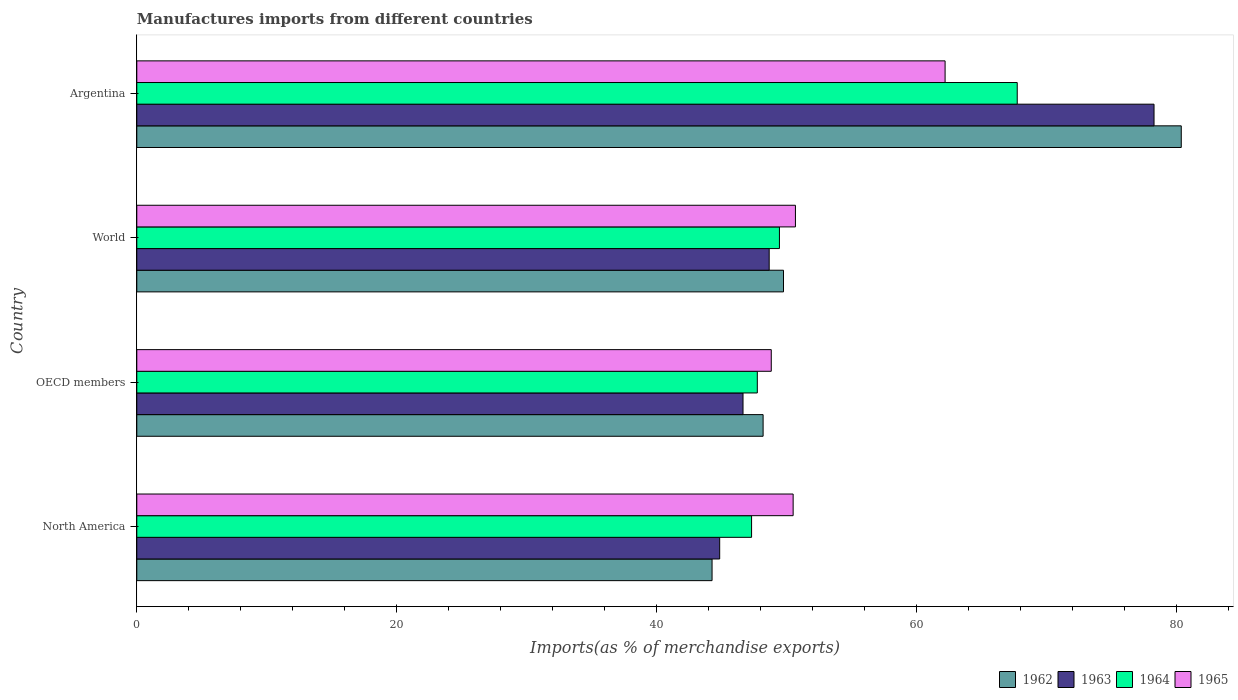How many groups of bars are there?
Give a very brief answer. 4. Are the number of bars on each tick of the Y-axis equal?
Your answer should be very brief. Yes. How many bars are there on the 1st tick from the bottom?
Provide a succinct answer. 4. What is the label of the 4th group of bars from the top?
Your answer should be very brief. North America. In how many cases, is the number of bars for a given country not equal to the number of legend labels?
Your answer should be very brief. 0. What is the percentage of imports to different countries in 1965 in World?
Your response must be concise. 50.68. Across all countries, what is the maximum percentage of imports to different countries in 1963?
Offer a terse response. 78.27. Across all countries, what is the minimum percentage of imports to different countries in 1962?
Give a very brief answer. 44.26. In which country was the percentage of imports to different countries in 1963 maximum?
Your response must be concise. Argentina. In which country was the percentage of imports to different countries in 1963 minimum?
Provide a short and direct response. North America. What is the total percentage of imports to different countries in 1962 in the graph?
Your answer should be compact. 222.58. What is the difference between the percentage of imports to different countries in 1963 in Argentina and that in OECD members?
Your answer should be compact. 31.62. What is the difference between the percentage of imports to different countries in 1964 in OECD members and the percentage of imports to different countries in 1963 in Argentina?
Your answer should be very brief. -30.53. What is the average percentage of imports to different countries in 1963 per country?
Provide a succinct answer. 54.61. What is the difference between the percentage of imports to different countries in 1965 and percentage of imports to different countries in 1964 in World?
Make the answer very short. 1.23. In how many countries, is the percentage of imports to different countries in 1964 greater than 60 %?
Keep it short and to the point. 1. What is the ratio of the percentage of imports to different countries in 1962 in Argentina to that in North America?
Your answer should be compact. 1.82. Is the percentage of imports to different countries in 1964 in North America less than that in OECD members?
Make the answer very short. Yes. What is the difference between the highest and the second highest percentage of imports to different countries in 1963?
Give a very brief answer. 29.61. What is the difference between the highest and the lowest percentage of imports to different countries in 1963?
Provide a short and direct response. 33.42. Is the sum of the percentage of imports to different countries in 1963 in OECD members and World greater than the maximum percentage of imports to different countries in 1965 across all countries?
Keep it short and to the point. Yes. Is it the case that in every country, the sum of the percentage of imports to different countries in 1963 and percentage of imports to different countries in 1964 is greater than the sum of percentage of imports to different countries in 1965 and percentage of imports to different countries in 1962?
Provide a short and direct response. No. What does the 3rd bar from the top in North America represents?
Provide a short and direct response. 1963. What does the 1st bar from the bottom in North America represents?
Make the answer very short. 1962. How many bars are there?
Make the answer very short. 16. How many countries are there in the graph?
Provide a short and direct response. 4. What is the difference between two consecutive major ticks on the X-axis?
Ensure brevity in your answer.  20. Are the values on the major ticks of X-axis written in scientific E-notation?
Your response must be concise. No. Does the graph contain any zero values?
Your answer should be very brief. No. Does the graph contain grids?
Keep it short and to the point. No. How many legend labels are there?
Your answer should be compact. 4. How are the legend labels stacked?
Make the answer very short. Horizontal. What is the title of the graph?
Ensure brevity in your answer.  Manufactures imports from different countries. Does "1995" appear as one of the legend labels in the graph?
Your response must be concise. No. What is the label or title of the X-axis?
Keep it short and to the point. Imports(as % of merchandise exports). What is the Imports(as % of merchandise exports) of 1962 in North America?
Your answer should be very brief. 44.26. What is the Imports(as % of merchandise exports) in 1963 in North America?
Keep it short and to the point. 44.85. What is the Imports(as % of merchandise exports) of 1964 in North America?
Keep it short and to the point. 47.3. What is the Imports(as % of merchandise exports) in 1965 in North America?
Your response must be concise. 50.5. What is the Imports(as % of merchandise exports) in 1962 in OECD members?
Your response must be concise. 48.19. What is the Imports(as % of merchandise exports) of 1963 in OECD members?
Keep it short and to the point. 46.65. What is the Imports(as % of merchandise exports) in 1964 in OECD members?
Your answer should be compact. 47.75. What is the Imports(as % of merchandise exports) in 1965 in OECD members?
Your answer should be compact. 48.82. What is the Imports(as % of merchandise exports) in 1962 in World?
Offer a terse response. 49.76. What is the Imports(as % of merchandise exports) of 1963 in World?
Give a very brief answer. 48.66. What is the Imports(as % of merchandise exports) of 1964 in World?
Provide a succinct answer. 49.45. What is the Imports(as % of merchandise exports) of 1965 in World?
Provide a short and direct response. 50.68. What is the Imports(as % of merchandise exports) of 1962 in Argentina?
Offer a terse response. 80.37. What is the Imports(as % of merchandise exports) in 1963 in Argentina?
Your response must be concise. 78.27. What is the Imports(as % of merchandise exports) in 1964 in Argentina?
Keep it short and to the point. 67.75. What is the Imports(as % of merchandise exports) in 1965 in Argentina?
Your answer should be very brief. 62.19. Across all countries, what is the maximum Imports(as % of merchandise exports) of 1962?
Offer a very short reply. 80.37. Across all countries, what is the maximum Imports(as % of merchandise exports) of 1963?
Offer a terse response. 78.27. Across all countries, what is the maximum Imports(as % of merchandise exports) in 1964?
Provide a succinct answer. 67.75. Across all countries, what is the maximum Imports(as % of merchandise exports) in 1965?
Your answer should be compact. 62.19. Across all countries, what is the minimum Imports(as % of merchandise exports) of 1962?
Make the answer very short. 44.26. Across all countries, what is the minimum Imports(as % of merchandise exports) of 1963?
Make the answer very short. 44.85. Across all countries, what is the minimum Imports(as % of merchandise exports) in 1964?
Offer a very short reply. 47.3. Across all countries, what is the minimum Imports(as % of merchandise exports) in 1965?
Your response must be concise. 48.82. What is the total Imports(as % of merchandise exports) in 1962 in the graph?
Your answer should be compact. 222.58. What is the total Imports(as % of merchandise exports) in 1963 in the graph?
Offer a terse response. 218.43. What is the total Imports(as % of merchandise exports) of 1964 in the graph?
Your answer should be very brief. 212.24. What is the total Imports(as % of merchandise exports) in 1965 in the graph?
Offer a terse response. 212.2. What is the difference between the Imports(as % of merchandise exports) of 1962 in North America and that in OECD members?
Give a very brief answer. -3.93. What is the difference between the Imports(as % of merchandise exports) of 1963 in North America and that in OECD members?
Your answer should be compact. -1.8. What is the difference between the Imports(as % of merchandise exports) in 1964 in North America and that in OECD members?
Your answer should be compact. -0.44. What is the difference between the Imports(as % of merchandise exports) of 1965 in North America and that in OECD members?
Make the answer very short. 1.68. What is the difference between the Imports(as % of merchandise exports) in 1962 in North America and that in World?
Make the answer very short. -5.5. What is the difference between the Imports(as % of merchandise exports) of 1963 in North America and that in World?
Offer a very short reply. -3.81. What is the difference between the Imports(as % of merchandise exports) of 1964 in North America and that in World?
Ensure brevity in your answer.  -2.14. What is the difference between the Imports(as % of merchandise exports) in 1965 in North America and that in World?
Your answer should be compact. -0.18. What is the difference between the Imports(as % of merchandise exports) in 1962 in North America and that in Argentina?
Offer a terse response. -36.1. What is the difference between the Imports(as % of merchandise exports) in 1963 in North America and that in Argentina?
Offer a terse response. -33.42. What is the difference between the Imports(as % of merchandise exports) of 1964 in North America and that in Argentina?
Give a very brief answer. -20.44. What is the difference between the Imports(as % of merchandise exports) of 1965 in North America and that in Argentina?
Provide a short and direct response. -11.69. What is the difference between the Imports(as % of merchandise exports) of 1962 in OECD members and that in World?
Your answer should be very brief. -1.57. What is the difference between the Imports(as % of merchandise exports) in 1963 in OECD members and that in World?
Keep it short and to the point. -2.01. What is the difference between the Imports(as % of merchandise exports) of 1964 in OECD members and that in World?
Give a very brief answer. -1.7. What is the difference between the Imports(as % of merchandise exports) in 1965 in OECD members and that in World?
Give a very brief answer. -1.86. What is the difference between the Imports(as % of merchandise exports) of 1962 in OECD members and that in Argentina?
Your answer should be compact. -32.17. What is the difference between the Imports(as % of merchandise exports) in 1963 in OECD members and that in Argentina?
Offer a very short reply. -31.62. What is the difference between the Imports(as % of merchandise exports) in 1964 in OECD members and that in Argentina?
Provide a short and direct response. -20. What is the difference between the Imports(as % of merchandise exports) of 1965 in OECD members and that in Argentina?
Your response must be concise. -13.38. What is the difference between the Imports(as % of merchandise exports) of 1962 in World and that in Argentina?
Provide a short and direct response. -30.61. What is the difference between the Imports(as % of merchandise exports) in 1963 in World and that in Argentina?
Your answer should be very brief. -29.61. What is the difference between the Imports(as % of merchandise exports) of 1964 in World and that in Argentina?
Your answer should be compact. -18.3. What is the difference between the Imports(as % of merchandise exports) in 1965 in World and that in Argentina?
Your response must be concise. -11.52. What is the difference between the Imports(as % of merchandise exports) of 1962 in North America and the Imports(as % of merchandise exports) of 1963 in OECD members?
Make the answer very short. -2.38. What is the difference between the Imports(as % of merchandise exports) in 1962 in North America and the Imports(as % of merchandise exports) in 1964 in OECD members?
Ensure brevity in your answer.  -3.48. What is the difference between the Imports(as % of merchandise exports) in 1962 in North America and the Imports(as % of merchandise exports) in 1965 in OECD members?
Provide a short and direct response. -4.56. What is the difference between the Imports(as % of merchandise exports) of 1963 in North America and the Imports(as % of merchandise exports) of 1964 in OECD members?
Your answer should be compact. -2.89. What is the difference between the Imports(as % of merchandise exports) in 1963 in North America and the Imports(as % of merchandise exports) in 1965 in OECD members?
Offer a very short reply. -3.97. What is the difference between the Imports(as % of merchandise exports) of 1964 in North America and the Imports(as % of merchandise exports) of 1965 in OECD members?
Offer a very short reply. -1.52. What is the difference between the Imports(as % of merchandise exports) of 1962 in North America and the Imports(as % of merchandise exports) of 1963 in World?
Make the answer very short. -4.4. What is the difference between the Imports(as % of merchandise exports) of 1962 in North America and the Imports(as % of merchandise exports) of 1964 in World?
Make the answer very short. -5.19. What is the difference between the Imports(as % of merchandise exports) of 1962 in North America and the Imports(as % of merchandise exports) of 1965 in World?
Keep it short and to the point. -6.42. What is the difference between the Imports(as % of merchandise exports) of 1963 in North America and the Imports(as % of merchandise exports) of 1964 in World?
Offer a terse response. -4.6. What is the difference between the Imports(as % of merchandise exports) of 1963 in North America and the Imports(as % of merchandise exports) of 1965 in World?
Your answer should be compact. -5.83. What is the difference between the Imports(as % of merchandise exports) in 1964 in North America and the Imports(as % of merchandise exports) in 1965 in World?
Provide a short and direct response. -3.37. What is the difference between the Imports(as % of merchandise exports) in 1962 in North America and the Imports(as % of merchandise exports) in 1963 in Argentina?
Provide a short and direct response. -34.01. What is the difference between the Imports(as % of merchandise exports) of 1962 in North America and the Imports(as % of merchandise exports) of 1964 in Argentina?
Offer a terse response. -23.48. What is the difference between the Imports(as % of merchandise exports) of 1962 in North America and the Imports(as % of merchandise exports) of 1965 in Argentina?
Your answer should be very brief. -17.93. What is the difference between the Imports(as % of merchandise exports) of 1963 in North America and the Imports(as % of merchandise exports) of 1964 in Argentina?
Your response must be concise. -22.89. What is the difference between the Imports(as % of merchandise exports) of 1963 in North America and the Imports(as % of merchandise exports) of 1965 in Argentina?
Your response must be concise. -17.34. What is the difference between the Imports(as % of merchandise exports) of 1964 in North America and the Imports(as % of merchandise exports) of 1965 in Argentina?
Offer a terse response. -14.89. What is the difference between the Imports(as % of merchandise exports) in 1962 in OECD members and the Imports(as % of merchandise exports) in 1963 in World?
Offer a very short reply. -0.47. What is the difference between the Imports(as % of merchandise exports) in 1962 in OECD members and the Imports(as % of merchandise exports) in 1964 in World?
Ensure brevity in your answer.  -1.26. What is the difference between the Imports(as % of merchandise exports) in 1962 in OECD members and the Imports(as % of merchandise exports) in 1965 in World?
Your response must be concise. -2.49. What is the difference between the Imports(as % of merchandise exports) in 1963 in OECD members and the Imports(as % of merchandise exports) in 1964 in World?
Make the answer very short. -2.8. What is the difference between the Imports(as % of merchandise exports) in 1963 in OECD members and the Imports(as % of merchandise exports) in 1965 in World?
Your answer should be very brief. -4.03. What is the difference between the Imports(as % of merchandise exports) of 1964 in OECD members and the Imports(as % of merchandise exports) of 1965 in World?
Offer a terse response. -2.93. What is the difference between the Imports(as % of merchandise exports) in 1962 in OECD members and the Imports(as % of merchandise exports) in 1963 in Argentina?
Keep it short and to the point. -30.08. What is the difference between the Imports(as % of merchandise exports) in 1962 in OECD members and the Imports(as % of merchandise exports) in 1964 in Argentina?
Your answer should be very brief. -19.55. What is the difference between the Imports(as % of merchandise exports) of 1962 in OECD members and the Imports(as % of merchandise exports) of 1965 in Argentina?
Your response must be concise. -14. What is the difference between the Imports(as % of merchandise exports) of 1963 in OECD members and the Imports(as % of merchandise exports) of 1964 in Argentina?
Keep it short and to the point. -21.1. What is the difference between the Imports(as % of merchandise exports) of 1963 in OECD members and the Imports(as % of merchandise exports) of 1965 in Argentina?
Keep it short and to the point. -15.55. What is the difference between the Imports(as % of merchandise exports) of 1964 in OECD members and the Imports(as % of merchandise exports) of 1965 in Argentina?
Provide a succinct answer. -14.45. What is the difference between the Imports(as % of merchandise exports) in 1962 in World and the Imports(as % of merchandise exports) in 1963 in Argentina?
Your answer should be very brief. -28.51. What is the difference between the Imports(as % of merchandise exports) of 1962 in World and the Imports(as % of merchandise exports) of 1964 in Argentina?
Make the answer very short. -17.98. What is the difference between the Imports(as % of merchandise exports) of 1962 in World and the Imports(as % of merchandise exports) of 1965 in Argentina?
Offer a terse response. -12.43. What is the difference between the Imports(as % of merchandise exports) of 1963 in World and the Imports(as % of merchandise exports) of 1964 in Argentina?
Provide a short and direct response. -19.09. What is the difference between the Imports(as % of merchandise exports) of 1963 in World and the Imports(as % of merchandise exports) of 1965 in Argentina?
Make the answer very short. -13.54. What is the difference between the Imports(as % of merchandise exports) in 1964 in World and the Imports(as % of merchandise exports) in 1965 in Argentina?
Keep it short and to the point. -12.75. What is the average Imports(as % of merchandise exports) in 1962 per country?
Make the answer very short. 55.65. What is the average Imports(as % of merchandise exports) of 1963 per country?
Make the answer very short. 54.61. What is the average Imports(as % of merchandise exports) of 1964 per country?
Provide a succinct answer. 53.06. What is the average Imports(as % of merchandise exports) in 1965 per country?
Your response must be concise. 53.05. What is the difference between the Imports(as % of merchandise exports) of 1962 and Imports(as % of merchandise exports) of 1963 in North America?
Your response must be concise. -0.59. What is the difference between the Imports(as % of merchandise exports) of 1962 and Imports(as % of merchandise exports) of 1964 in North America?
Keep it short and to the point. -3.04. What is the difference between the Imports(as % of merchandise exports) of 1962 and Imports(as % of merchandise exports) of 1965 in North America?
Provide a succinct answer. -6.24. What is the difference between the Imports(as % of merchandise exports) of 1963 and Imports(as % of merchandise exports) of 1964 in North America?
Provide a short and direct response. -2.45. What is the difference between the Imports(as % of merchandise exports) in 1963 and Imports(as % of merchandise exports) in 1965 in North America?
Give a very brief answer. -5.65. What is the difference between the Imports(as % of merchandise exports) in 1964 and Imports(as % of merchandise exports) in 1965 in North America?
Provide a succinct answer. -3.2. What is the difference between the Imports(as % of merchandise exports) in 1962 and Imports(as % of merchandise exports) in 1963 in OECD members?
Keep it short and to the point. 1.55. What is the difference between the Imports(as % of merchandise exports) of 1962 and Imports(as % of merchandise exports) of 1964 in OECD members?
Keep it short and to the point. 0.45. What is the difference between the Imports(as % of merchandise exports) of 1962 and Imports(as % of merchandise exports) of 1965 in OECD members?
Ensure brevity in your answer.  -0.63. What is the difference between the Imports(as % of merchandise exports) of 1963 and Imports(as % of merchandise exports) of 1964 in OECD members?
Your answer should be compact. -1.1. What is the difference between the Imports(as % of merchandise exports) of 1963 and Imports(as % of merchandise exports) of 1965 in OECD members?
Provide a succinct answer. -2.17. What is the difference between the Imports(as % of merchandise exports) of 1964 and Imports(as % of merchandise exports) of 1965 in OECD members?
Provide a short and direct response. -1.07. What is the difference between the Imports(as % of merchandise exports) of 1962 and Imports(as % of merchandise exports) of 1963 in World?
Make the answer very short. 1.1. What is the difference between the Imports(as % of merchandise exports) of 1962 and Imports(as % of merchandise exports) of 1964 in World?
Your response must be concise. 0.31. What is the difference between the Imports(as % of merchandise exports) of 1962 and Imports(as % of merchandise exports) of 1965 in World?
Keep it short and to the point. -0.92. What is the difference between the Imports(as % of merchandise exports) of 1963 and Imports(as % of merchandise exports) of 1964 in World?
Your answer should be very brief. -0.79. What is the difference between the Imports(as % of merchandise exports) of 1963 and Imports(as % of merchandise exports) of 1965 in World?
Offer a very short reply. -2.02. What is the difference between the Imports(as % of merchandise exports) of 1964 and Imports(as % of merchandise exports) of 1965 in World?
Your answer should be very brief. -1.23. What is the difference between the Imports(as % of merchandise exports) of 1962 and Imports(as % of merchandise exports) of 1963 in Argentina?
Make the answer very short. 2.1. What is the difference between the Imports(as % of merchandise exports) in 1962 and Imports(as % of merchandise exports) in 1964 in Argentina?
Keep it short and to the point. 12.62. What is the difference between the Imports(as % of merchandise exports) in 1962 and Imports(as % of merchandise exports) in 1965 in Argentina?
Offer a very short reply. 18.17. What is the difference between the Imports(as % of merchandise exports) of 1963 and Imports(as % of merchandise exports) of 1964 in Argentina?
Give a very brief answer. 10.52. What is the difference between the Imports(as % of merchandise exports) of 1963 and Imports(as % of merchandise exports) of 1965 in Argentina?
Your answer should be compact. 16.08. What is the difference between the Imports(as % of merchandise exports) of 1964 and Imports(as % of merchandise exports) of 1965 in Argentina?
Provide a short and direct response. 5.55. What is the ratio of the Imports(as % of merchandise exports) of 1962 in North America to that in OECD members?
Your answer should be compact. 0.92. What is the ratio of the Imports(as % of merchandise exports) of 1963 in North America to that in OECD members?
Provide a succinct answer. 0.96. What is the ratio of the Imports(as % of merchandise exports) of 1965 in North America to that in OECD members?
Offer a very short reply. 1.03. What is the ratio of the Imports(as % of merchandise exports) of 1962 in North America to that in World?
Provide a short and direct response. 0.89. What is the ratio of the Imports(as % of merchandise exports) in 1963 in North America to that in World?
Offer a terse response. 0.92. What is the ratio of the Imports(as % of merchandise exports) of 1964 in North America to that in World?
Give a very brief answer. 0.96. What is the ratio of the Imports(as % of merchandise exports) of 1962 in North America to that in Argentina?
Give a very brief answer. 0.55. What is the ratio of the Imports(as % of merchandise exports) in 1963 in North America to that in Argentina?
Your answer should be very brief. 0.57. What is the ratio of the Imports(as % of merchandise exports) of 1964 in North America to that in Argentina?
Keep it short and to the point. 0.7. What is the ratio of the Imports(as % of merchandise exports) of 1965 in North America to that in Argentina?
Give a very brief answer. 0.81. What is the ratio of the Imports(as % of merchandise exports) of 1962 in OECD members to that in World?
Your answer should be compact. 0.97. What is the ratio of the Imports(as % of merchandise exports) of 1963 in OECD members to that in World?
Offer a very short reply. 0.96. What is the ratio of the Imports(as % of merchandise exports) of 1964 in OECD members to that in World?
Provide a succinct answer. 0.97. What is the ratio of the Imports(as % of merchandise exports) in 1965 in OECD members to that in World?
Ensure brevity in your answer.  0.96. What is the ratio of the Imports(as % of merchandise exports) of 1962 in OECD members to that in Argentina?
Provide a short and direct response. 0.6. What is the ratio of the Imports(as % of merchandise exports) of 1963 in OECD members to that in Argentina?
Your answer should be compact. 0.6. What is the ratio of the Imports(as % of merchandise exports) in 1964 in OECD members to that in Argentina?
Provide a short and direct response. 0.7. What is the ratio of the Imports(as % of merchandise exports) in 1965 in OECD members to that in Argentina?
Your answer should be compact. 0.78. What is the ratio of the Imports(as % of merchandise exports) in 1962 in World to that in Argentina?
Make the answer very short. 0.62. What is the ratio of the Imports(as % of merchandise exports) in 1963 in World to that in Argentina?
Make the answer very short. 0.62. What is the ratio of the Imports(as % of merchandise exports) in 1964 in World to that in Argentina?
Provide a succinct answer. 0.73. What is the ratio of the Imports(as % of merchandise exports) in 1965 in World to that in Argentina?
Make the answer very short. 0.81. What is the difference between the highest and the second highest Imports(as % of merchandise exports) in 1962?
Your response must be concise. 30.61. What is the difference between the highest and the second highest Imports(as % of merchandise exports) of 1963?
Your answer should be compact. 29.61. What is the difference between the highest and the second highest Imports(as % of merchandise exports) of 1964?
Make the answer very short. 18.3. What is the difference between the highest and the second highest Imports(as % of merchandise exports) of 1965?
Ensure brevity in your answer.  11.52. What is the difference between the highest and the lowest Imports(as % of merchandise exports) of 1962?
Ensure brevity in your answer.  36.1. What is the difference between the highest and the lowest Imports(as % of merchandise exports) in 1963?
Make the answer very short. 33.42. What is the difference between the highest and the lowest Imports(as % of merchandise exports) in 1964?
Your answer should be very brief. 20.44. What is the difference between the highest and the lowest Imports(as % of merchandise exports) in 1965?
Provide a short and direct response. 13.38. 